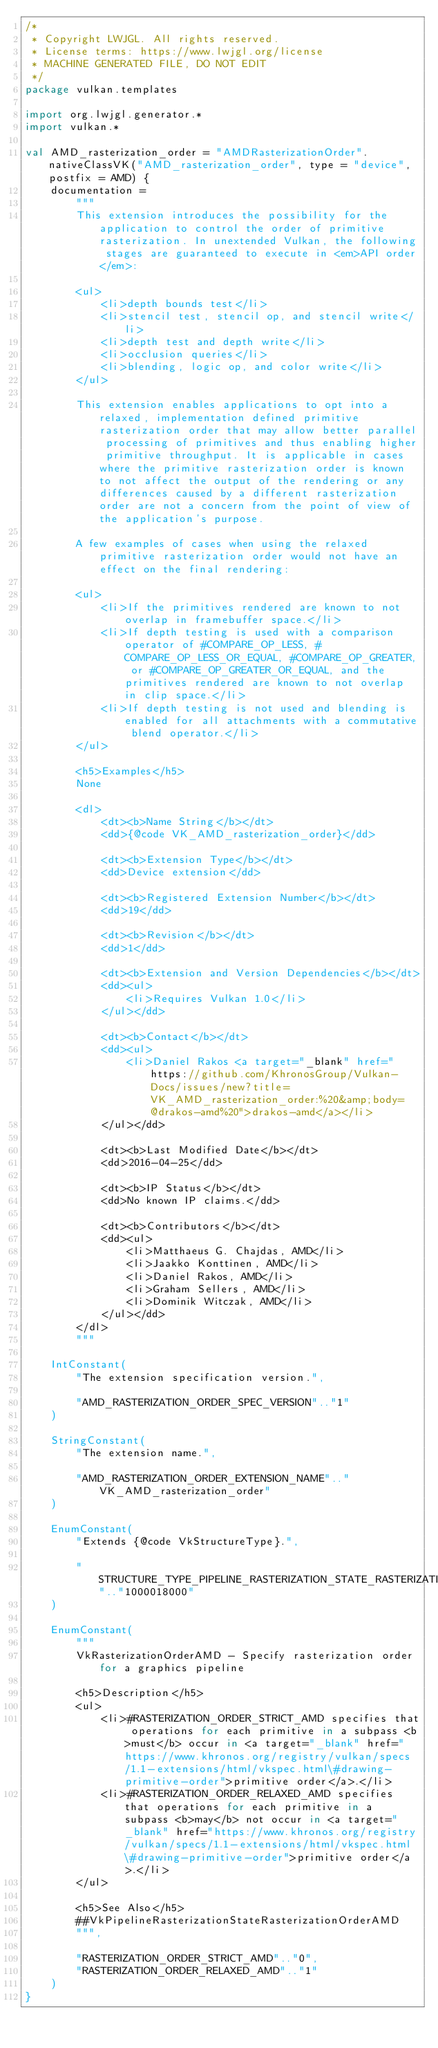<code> <loc_0><loc_0><loc_500><loc_500><_Kotlin_>/*
 * Copyright LWJGL. All rights reserved.
 * License terms: https://www.lwjgl.org/license
 * MACHINE GENERATED FILE, DO NOT EDIT
 */
package vulkan.templates

import org.lwjgl.generator.*
import vulkan.*

val AMD_rasterization_order = "AMDRasterizationOrder".nativeClassVK("AMD_rasterization_order", type = "device", postfix = AMD) {
    documentation =
        """
        This extension introduces the possibility for the application to control the order of primitive rasterization. In unextended Vulkan, the following stages are guaranteed to execute in <em>API order</em>:

        <ul>
            <li>depth bounds test</li>
            <li>stencil test, stencil op, and stencil write</li>
            <li>depth test and depth write</li>
            <li>occlusion queries</li>
            <li>blending, logic op, and color write</li>
        </ul>

        This extension enables applications to opt into a relaxed, implementation defined primitive rasterization order that may allow better parallel processing of primitives and thus enabling higher primitive throughput. It is applicable in cases where the primitive rasterization order is known to not affect the output of the rendering or any differences caused by a different rasterization order are not a concern from the point of view of the application's purpose.

        A few examples of cases when using the relaxed primitive rasterization order would not have an effect on the final rendering:

        <ul>
            <li>If the primitives rendered are known to not overlap in framebuffer space.</li>
            <li>If depth testing is used with a comparison operator of #COMPARE_OP_LESS, #COMPARE_OP_LESS_OR_EQUAL, #COMPARE_OP_GREATER, or #COMPARE_OP_GREATER_OR_EQUAL, and the primitives rendered are known to not overlap in clip space.</li>
            <li>If depth testing is not used and blending is enabled for all attachments with a commutative blend operator.</li>
        </ul>

        <h5>Examples</h5>
        None

        <dl>
            <dt><b>Name String</b></dt>
            <dd>{@code VK_AMD_rasterization_order}</dd>

            <dt><b>Extension Type</b></dt>
            <dd>Device extension</dd>

            <dt><b>Registered Extension Number</b></dt>
            <dd>19</dd>

            <dt><b>Revision</b></dt>
            <dd>1</dd>

            <dt><b>Extension and Version Dependencies</b></dt>
            <dd><ul>
                <li>Requires Vulkan 1.0</li>
            </ul></dd>

            <dt><b>Contact</b></dt>
            <dd><ul>
                <li>Daniel Rakos <a target="_blank" href="https://github.com/KhronosGroup/Vulkan-Docs/issues/new?title=VK_AMD_rasterization_order:%20&amp;body=@drakos-amd%20">drakos-amd</a></li>
            </ul></dd>

            <dt><b>Last Modified Date</b></dt>
            <dd>2016-04-25</dd>

            <dt><b>IP Status</b></dt>
            <dd>No known IP claims.</dd>

            <dt><b>Contributors</b></dt>
            <dd><ul>
                <li>Matthaeus G. Chajdas, AMD</li>
                <li>Jaakko Konttinen, AMD</li>
                <li>Daniel Rakos, AMD</li>
                <li>Graham Sellers, AMD</li>
                <li>Dominik Witczak, AMD</li>
            </ul></dd>
        </dl>
        """

    IntConstant(
        "The extension specification version.",

        "AMD_RASTERIZATION_ORDER_SPEC_VERSION".."1"
    )

    StringConstant(
        "The extension name.",

        "AMD_RASTERIZATION_ORDER_EXTENSION_NAME".."VK_AMD_rasterization_order"
    )

    EnumConstant(
        "Extends {@code VkStructureType}.",

        "STRUCTURE_TYPE_PIPELINE_RASTERIZATION_STATE_RASTERIZATION_ORDER_AMD".."1000018000"
    )

    EnumConstant(
        """
        VkRasterizationOrderAMD - Specify rasterization order for a graphics pipeline

        <h5>Description</h5>
        <ul>
            <li>#RASTERIZATION_ORDER_STRICT_AMD specifies that operations for each primitive in a subpass <b>must</b> occur in <a target="_blank" href="https://www.khronos.org/registry/vulkan/specs/1.1-extensions/html/vkspec.html\#drawing-primitive-order">primitive order</a>.</li>
            <li>#RASTERIZATION_ORDER_RELAXED_AMD specifies that operations for each primitive in a subpass <b>may</b> not occur in <a target="_blank" href="https://www.khronos.org/registry/vulkan/specs/1.1-extensions/html/vkspec.html\#drawing-primitive-order">primitive order</a>.</li>
        </ul>

        <h5>See Also</h5>
        ##VkPipelineRasterizationStateRasterizationOrderAMD
        """,

        "RASTERIZATION_ORDER_STRICT_AMD".."0",
        "RASTERIZATION_ORDER_RELAXED_AMD".."1"
    )
}</code> 